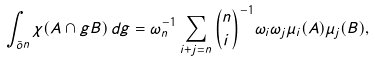Convert formula to latex. <formula><loc_0><loc_0><loc_500><loc_500>\int _ { \bar { o } n } \chi ( A \cap g B ) \, d g = \omega ^ { - 1 } _ { n } \sum _ { i + j = n } \binom { n } { i } ^ { - 1 } \omega _ { i } \omega _ { j } \mu _ { i } ( A ) \mu _ { j } ( B ) ,</formula> 